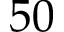Convert formula to latex. <formula><loc_0><loc_0><loc_500><loc_500>5 0</formula> 